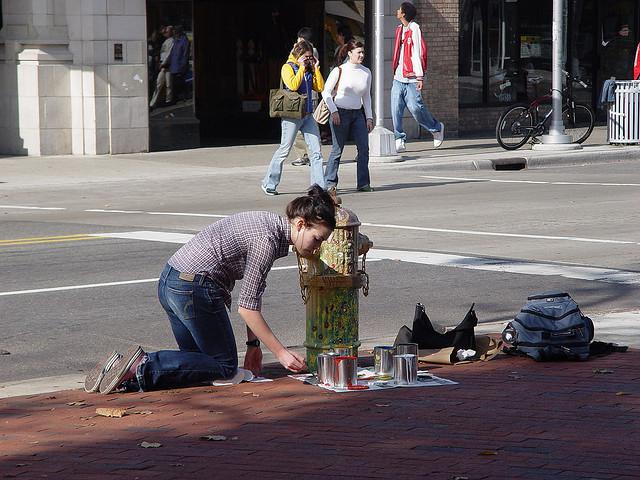What type of art is being created?
Keep it brief. Graffiti. What color is the backpack on the ground?
Write a very short answer. Blue. Where should she put the newspaper when she is ready to throw it away?
Be succinct. Trash can. Is the girl sitting on the sidewalk?
Short answer required. Yes. 